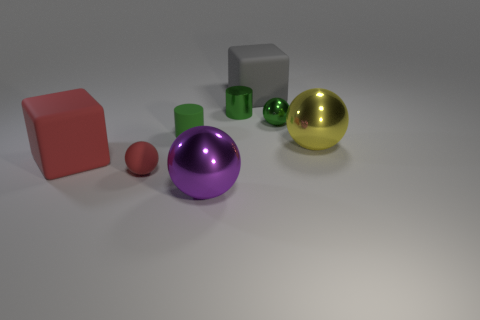What is the shape of the big rubber object that is the same color as the tiny matte ball?
Ensure brevity in your answer.  Cube. What is the shape of the red rubber object to the right of the matte block that is in front of the green metal sphere?
Provide a short and direct response. Sphere. What number of rubber cubes are the same size as the green metallic ball?
Offer a very short reply. 0. Are there any small rubber spheres?
Ensure brevity in your answer.  Yes. Is there any other thing that has the same color as the tiny metal cylinder?
Make the answer very short. Yes. There is a large purple thing that is made of the same material as the large yellow object; what shape is it?
Ensure brevity in your answer.  Sphere. What color is the big block that is behind the tiny sphere that is to the right of the big matte cube that is on the right side of the big purple metal thing?
Your response must be concise. Gray. Are there the same number of gray blocks to the left of the green matte thing and big shiny objects?
Make the answer very short. No. Is there anything else that is made of the same material as the gray thing?
Ensure brevity in your answer.  Yes. There is a matte cylinder; does it have the same color as the large metallic thing behind the tiny rubber sphere?
Offer a terse response. No. 